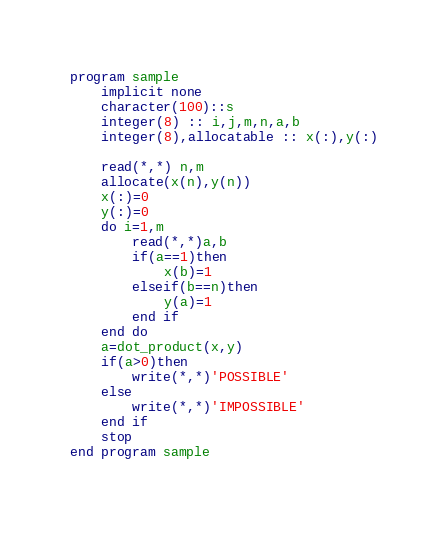<code> <loc_0><loc_0><loc_500><loc_500><_FORTRAN_>program sample
    implicit none
    character(100)::s
    integer(8) :: i,j,m,n,a,b
    integer(8),allocatable :: x(:),y(:)
  
    read(*,*) n,m
    allocate(x(n),y(n))
    x(:)=0
    y(:)=0
    do i=1,m
        read(*,*)a,b
        if(a==1)then
            x(b)=1
        elseif(b==n)then
            y(a)=1
        end if
    end do
    a=dot_product(x,y)
    if(a>0)then
        write(*,*)'POSSIBLE'
    else
        write(*,*)'IMPOSSIBLE'
    end if
    stop
end program sample
  

</code> 